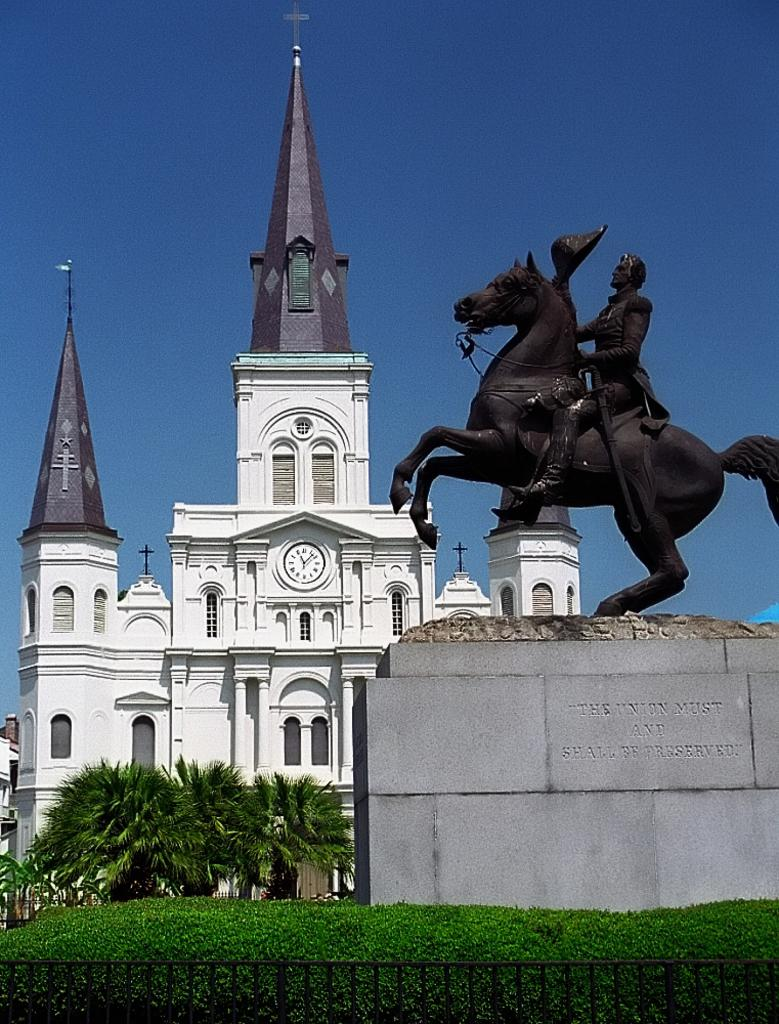What is the main subject of the image? There is a statue in the image. Can you describe the statue? The statue is of a person sitting on a horse. What type of natural environment is visible in the image? There is grass and trees in the image. What can be seen in the background of the image? There is a building in the background of the image. How would you describe the weather in the image? The sky is clear in the image, suggesting good weather. What type of attraction is the statue a part of in the image? There is no indication in the image that the statue is a part of any attraction. How does the person on the horse slip off in the image? The person on the horse does not slip off in the image; the statue is stationary. 